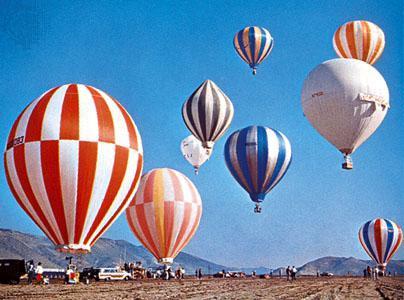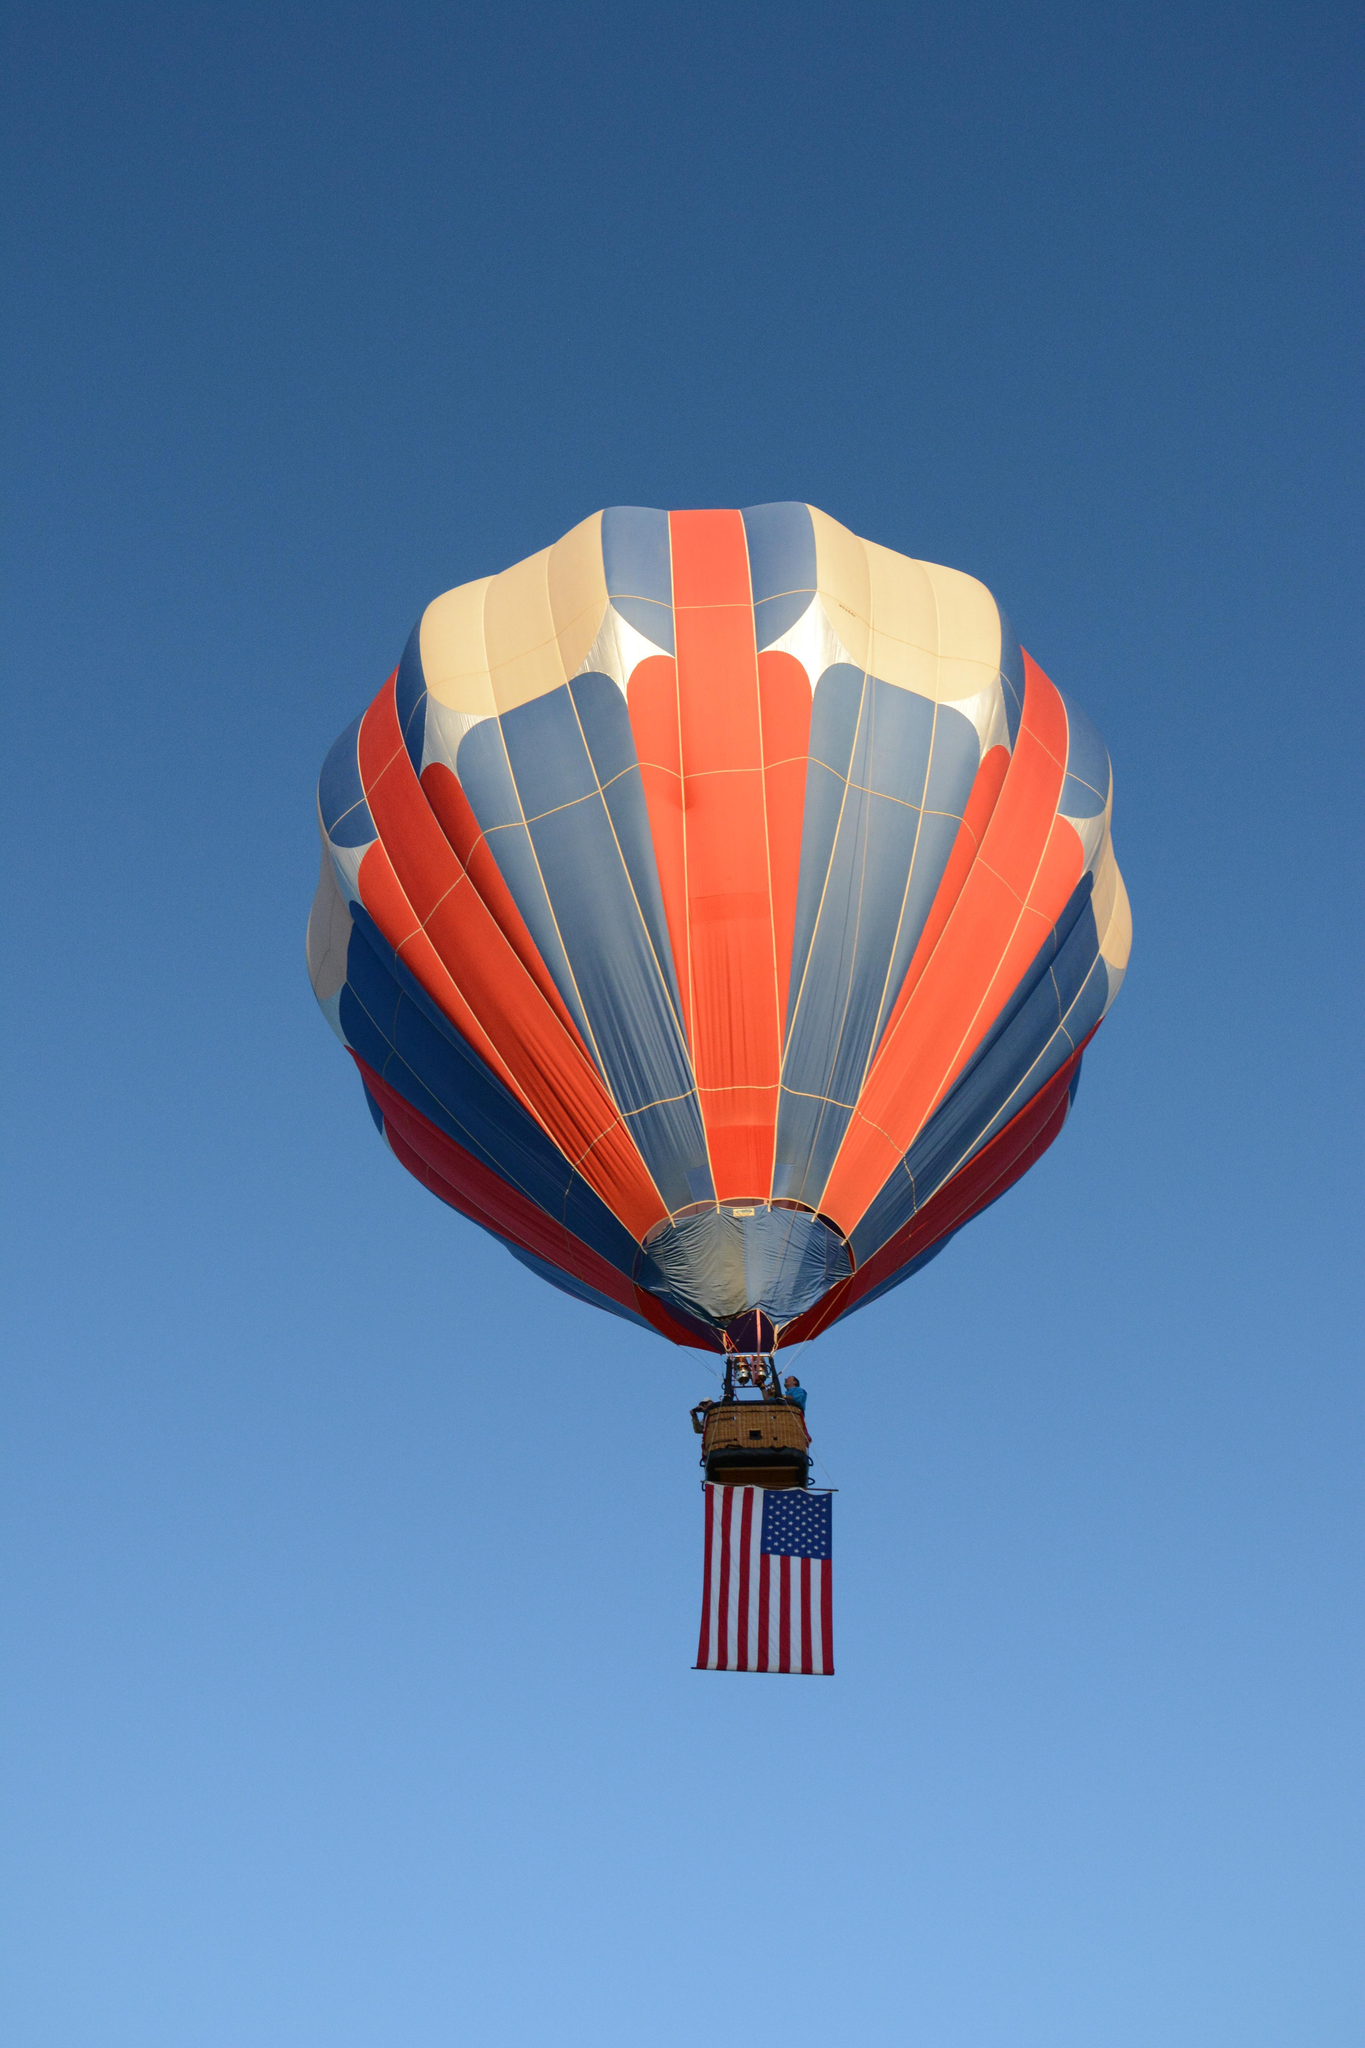The first image is the image on the left, the second image is the image on the right. Examine the images to the left and right. Is the description "A total of two hot air balloons with wicker baskets attached below are shown against the sky." accurate? Answer yes or no. No. 